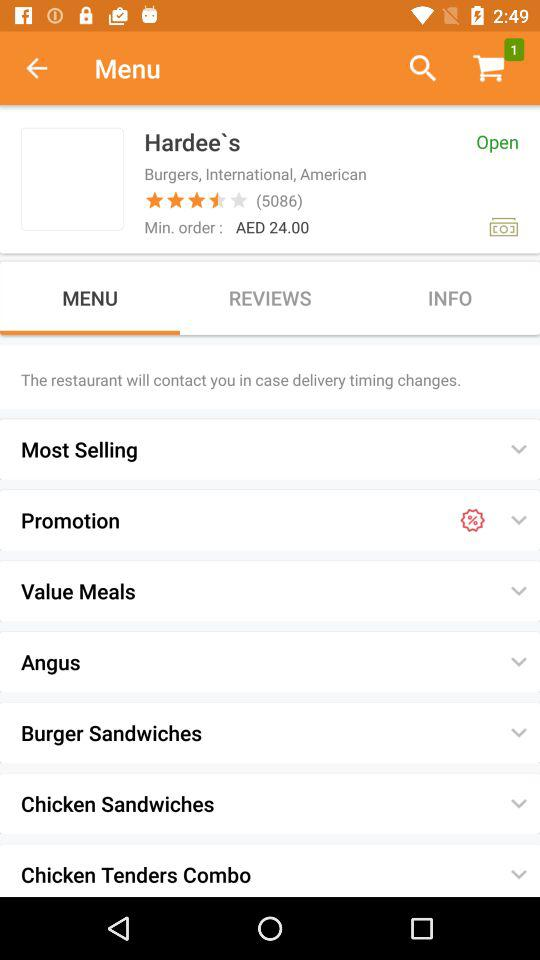What is the rating of the restaurant? The rating of the restaurant is 3.5 stars. 